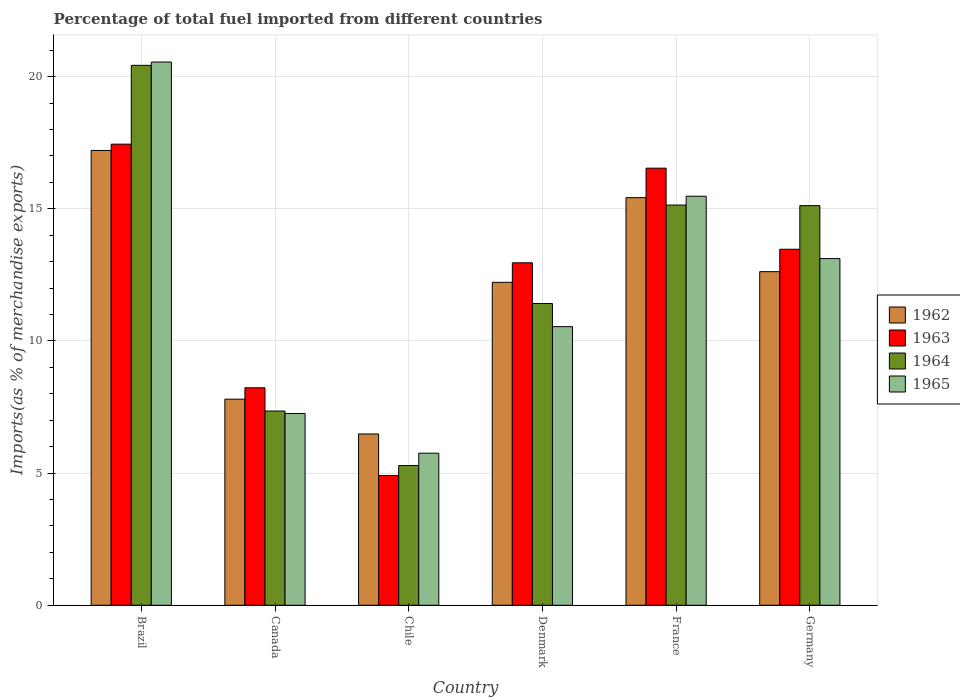How many different coloured bars are there?
Keep it short and to the point. 4. How many groups of bars are there?
Offer a very short reply. 6. Are the number of bars per tick equal to the number of legend labels?
Ensure brevity in your answer.  Yes. How many bars are there on the 2nd tick from the right?
Make the answer very short. 4. What is the label of the 1st group of bars from the left?
Your answer should be compact. Brazil. In how many cases, is the number of bars for a given country not equal to the number of legend labels?
Offer a terse response. 0. What is the percentage of imports to different countries in 1963 in Chile?
Ensure brevity in your answer.  4.91. Across all countries, what is the maximum percentage of imports to different countries in 1962?
Keep it short and to the point. 17.21. Across all countries, what is the minimum percentage of imports to different countries in 1962?
Provide a succinct answer. 6.48. What is the total percentage of imports to different countries in 1962 in the graph?
Give a very brief answer. 71.75. What is the difference between the percentage of imports to different countries in 1965 in Denmark and that in Germany?
Keep it short and to the point. -2.58. What is the difference between the percentage of imports to different countries in 1962 in Denmark and the percentage of imports to different countries in 1965 in Canada?
Provide a short and direct response. 4.96. What is the average percentage of imports to different countries in 1964 per country?
Give a very brief answer. 12.46. What is the difference between the percentage of imports to different countries of/in 1963 and percentage of imports to different countries of/in 1964 in Germany?
Your response must be concise. -1.65. In how many countries, is the percentage of imports to different countries in 1963 greater than 15 %?
Your answer should be very brief. 2. What is the ratio of the percentage of imports to different countries in 1964 in Chile to that in France?
Keep it short and to the point. 0.35. Is the difference between the percentage of imports to different countries in 1963 in Brazil and Chile greater than the difference between the percentage of imports to different countries in 1964 in Brazil and Chile?
Offer a very short reply. No. What is the difference between the highest and the second highest percentage of imports to different countries in 1965?
Offer a terse response. 7.44. What is the difference between the highest and the lowest percentage of imports to different countries in 1964?
Ensure brevity in your answer.  15.14. In how many countries, is the percentage of imports to different countries in 1965 greater than the average percentage of imports to different countries in 1965 taken over all countries?
Your answer should be very brief. 3. What does the 4th bar from the right in Canada represents?
Your answer should be very brief. 1962. Is it the case that in every country, the sum of the percentage of imports to different countries in 1963 and percentage of imports to different countries in 1962 is greater than the percentage of imports to different countries in 1964?
Offer a terse response. Yes. How many countries are there in the graph?
Your answer should be very brief. 6. What is the difference between two consecutive major ticks on the Y-axis?
Keep it short and to the point. 5. Are the values on the major ticks of Y-axis written in scientific E-notation?
Your response must be concise. No. Does the graph contain any zero values?
Give a very brief answer. No. Does the graph contain grids?
Make the answer very short. Yes. What is the title of the graph?
Provide a succinct answer. Percentage of total fuel imported from different countries. Does "2005" appear as one of the legend labels in the graph?
Your answer should be very brief. No. What is the label or title of the X-axis?
Your answer should be very brief. Country. What is the label or title of the Y-axis?
Keep it short and to the point. Imports(as % of merchandise exports). What is the Imports(as % of merchandise exports) of 1962 in Brazil?
Your answer should be compact. 17.21. What is the Imports(as % of merchandise exports) of 1963 in Brazil?
Provide a succinct answer. 17.45. What is the Imports(as % of merchandise exports) in 1964 in Brazil?
Keep it short and to the point. 20.43. What is the Imports(as % of merchandise exports) in 1965 in Brazil?
Your answer should be compact. 20.55. What is the Imports(as % of merchandise exports) of 1962 in Canada?
Give a very brief answer. 7.8. What is the Imports(as % of merchandise exports) of 1963 in Canada?
Offer a very short reply. 8.23. What is the Imports(as % of merchandise exports) in 1964 in Canada?
Provide a succinct answer. 7.35. What is the Imports(as % of merchandise exports) in 1965 in Canada?
Your response must be concise. 7.26. What is the Imports(as % of merchandise exports) of 1962 in Chile?
Offer a very short reply. 6.48. What is the Imports(as % of merchandise exports) in 1963 in Chile?
Ensure brevity in your answer.  4.91. What is the Imports(as % of merchandise exports) of 1964 in Chile?
Provide a succinct answer. 5.29. What is the Imports(as % of merchandise exports) in 1965 in Chile?
Provide a short and direct response. 5.75. What is the Imports(as % of merchandise exports) in 1962 in Denmark?
Offer a very short reply. 12.22. What is the Imports(as % of merchandise exports) of 1963 in Denmark?
Your response must be concise. 12.96. What is the Imports(as % of merchandise exports) of 1964 in Denmark?
Make the answer very short. 11.42. What is the Imports(as % of merchandise exports) in 1965 in Denmark?
Your response must be concise. 10.54. What is the Imports(as % of merchandise exports) of 1962 in France?
Make the answer very short. 15.42. What is the Imports(as % of merchandise exports) of 1963 in France?
Keep it short and to the point. 16.54. What is the Imports(as % of merchandise exports) of 1964 in France?
Offer a terse response. 15.14. What is the Imports(as % of merchandise exports) in 1965 in France?
Offer a very short reply. 15.48. What is the Imports(as % of merchandise exports) in 1962 in Germany?
Your answer should be very brief. 12.62. What is the Imports(as % of merchandise exports) in 1963 in Germany?
Keep it short and to the point. 13.47. What is the Imports(as % of merchandise exports) of 1964 in Germany?
Offer a terse response. 15.12. What is the Imports(as % of merchandise exports) in 1965 in Germany?
Provide a succinct answer. 13.12. Across all countries, what is the maximum Imports(as % of merchandise exports) of 1962?
Provide a short and direct response. 17.21. Across all countries, what is the maximum Imports(as % of merchandise exports) of 1963?
Provide a short and direct response. 17.45. Across all countries, what is the maximum Imports(as % of merchandise exports) in 1964?
Offer a terse response. 20.43. Across all countries, what is the maximum Imports(as % of merchandise exports) of 1965?
Give a very brief answer. 20.55. Across all countries, what is the minimum Imports(as % of merchandise exports) of 1962?
Your response must be concise. 6.48. Across all countries, what is the minimum Imports(as % of merchandise exports) in 1963?
Provide a succinct answer. 4.91. Across all countries, what is the minimum Imports(as % of merchandise exports) in 1964?
Offer a very short reply. 5.29. Across all countries, what is the minimum Imports(as % of merchandise exports) in 1965?
Provide a short and direct response. 5.75. What is the total Imports(as % of merchandise exports) in 1962 in the graph?
Provide a succinct answer. 71.75. What is the total Imports(as % of merchandise exports) of 1963 in the graph?
Your response must be concise. 73.55. What is the total Imports(as % of merchandise exports) of 1964 in the graph?
Offer a terse response. 74.75. What is the total Imports(as % of merchandise exports) of 1965 in the graph?
Keep it short and to the point. 72.7. What is the difference between the Imports(as % of merchandise exports) in 1962 in Brazil and that in Canada?
Your answer should be compact. 9.41. What is the difference between the Imports(as % of merchandise exports) of 1963 in Brazil and that in Canada?
Ensure brevity in your answer.  9.22. What is the difference between the Imports(as % of merchandise exports) of 1964 in Brazil and that in Canada?
Offer a very short reply. 13.08. What is the difference between the Imports(as % of merchandise exports) of 1965 in Brazil and that in Canada?
Your answer should be very brief. 13.3. What is the difference between the Imports(as % of merchandise exports) in 1962 in Brazil and that in Chile?
Ensure brevity in your answer.  10.73. What is the difference between the Imports(as % of merchandise exports) of 1963 in Brazil and that in Chile?
Provide a succinct answer. 12.54. What is the difference between the Imports(as % of merchandise exports) in 1964 in Brazil and that in Chile?
Keep it short and to the point. 15.14. What is the difference between the Imports(as % of merchandise exports) in 1965 in Brazil and that in Chile?
Make the answer very short. 14.8. What is the difference between the Imports(as % of merchandise exports) in 1962 in Brazil and that in Denmark?
Make the answer very short. 4.99. What is the difference between the Imports(as % of merchandise exports) in 1963 in Brazil and that in Denmark?
Your answer should be compact. 4.49. What is the difference between the Imports(as % of merchandise exports) in 1964 in Brazil and that in Denmark?
Your answer should be very brief. 9.01. What is the difference between the Imports(as % of merchandise exports) in 1965 in Brazil and that in Denmark?
Your response must be concise. 10.01. What is the difference between the Imports(as % of merchandise exports) in 1962 in Brazil and that in France?
Give a very brief answer. 1.79. What is the difference between the Imports(as % of merchandise exports) of 1963 in Brazil and that in France?
Keep it short and to the point. 0.91. What is the difference between the Imports(as % of merchandise exports) in 1964 in Brazil and that in France?
Provide a short and direct response. 5.29. What is the difference between the Imports(as % of merchandise exports) in 1965 in Brazil and that in France?
Offer a terse response. 5.08. What is the difference between the Imports(as % of merchandise exports) of 1962 in Brazil and that in Germany?
Give a very brief answer. 4.59. What is the difference between the Imports(as % of merchandise exports) of 1963 in Brazil and that in Germany?
Keep it short and to the point. 3.98. What is the difference between the Imports(as % of merchandise exports) of 1964 in Brazil and that in Germany?
Provide a short and direct response. 5.31. What is the difference between the Imports(as % of merchandise exports) in 1965 in Brazil and that in Germany?
Your answer should be compact. 7.44. What is the difference between the Imports(as % of merchandise exports) of 1962 in Canada and that in Chile?
Your answer should be compact. 1.32. What is the difference between the Imports(as % of merchandise exports) in 1963 in Canada and that in Chile?
Offer a terse response. 3.32. What is the difference between the Imports(as % of merchandise exports) of 1964 in Canada and that in Chile?
Your answer should be compact. 2.06. What is the difference between the Imports(as % of merchandise exports) of 1965 in Canada and that in Chile?
Keep it short and to the point. 1.5. What is the difference between the Imports(as % of merchandise exports) of 1962 in Canada and that in Denmark?
Your answer should be compact. -4.42. What is the difference between the Imports(as % of merchandise exports) of 1963 in Canada and that in Denmark?
Keep it short and to the point. -4.73. What is the difference between the Imports(as % of merchandise exports) in 1964 in Canada and that in Denmark?
Offer a terse response. -4.07. What is the difference between the Imports(as % of merchandise exports) of 1965 in Canada and that in Denmark?
Make the answer very short. -3.29. What is the difference between the Imports(as % of merchandise exports) of 1962 in Canada and that in France?
Your answer should be very brief. -7.62. What is the difference between the Imports(as % of merchandise exports) of 1963 in Canada and that in France?
Provide a short and direct response. -8.31. What is the difference between the Imports(as % of merchandise exports) in 1964 in Canada and that in France?
Provide a short and direct response. -7.79. What is the difference between the Imports(as % of merchandise exports) in 1965 in Canada and that in France?
Provide a short and direct response. -8.22. What is the difference between the Imports(as % of merchandise exports) in 1962 in Canada and that in Germany?
Your response must be concise. -4.82. What is the difference between the Imports(as % of merchandise exports) in 1963 in Canada and that in Germany?
Keep it short and to the point. -5.24. What is the difference between the Imports(as % of merchandise exports) of 1964 in Canada and that in Germany?
Make the answer very short. -7.77. What is the difference between the Imports(as % of merchandise exports) of 1965 in Canada and that in Germany?
Provide a short and direct response. -5.86. What is the difference between the Imports(as % of merchandise exports) of 1962 in Chile and that in Denmark?
Your response must be concise. -5.74. What is the difference between the Imports(as % of merchandise exports) in 1963 in Chile and that in Denmark?
Keep it short and to the point. -8.05. What is the difference between the Imports(as % of merchandise exports) in 1964 in Chile and that in Denmark?
Ensure brevity in your answer.  -6.13. What is the difference between the Imports(as % of merchandise exports) of 1965 in Chile and that in Denmark?
Offer a very short reply. -4.79. What is the difference between the Imports(as % of merchandise exports) in 1962 in Chile and that in France?
Offer a very short reply. -8.94. What is the difference between the Imports(as % of merchandise exports) in 1963 in Chile and that in France?
Your response must be concise. -11.63. What is the difference between the Imports(as % of merchandise exports) of 1964 in Chile and that in France?
Offer a terse response. -9.86. What is the difference between the Imports(as % of merchandise exports) of 1965 in Chile and that in France?
Provide a short and direct response. -9.72. What is the difference between the Imports(as % of merchandise exports) of 1962 in Chile and that in Germany?
Offer a very short reply. -6.14. What is the difference between the Imports(as % of merchandise exports) of 1963 in Chile and that in Germany?
Provide a succinct answer. -8.56. What is the difference between the Imports(as % of merchandise exports) in 1964 in Chile and that in Germany?
Offer a very short reply. -9.83. What is the difference between the Imports(as % of merchandise exports) in 1965 in Chile and that in Germany?
Provide a succinct answer. -7.36. What is the difference between the Imports(as % of merchandise exports) of 1962 in Denmark and that in France?
Provide a short and direct response. -3.2. What is the difference between the Imports(as % of merchandise exports) in 1963 in Denmark and that in France?
Make the answer very short. -3.58. What is the difference between the Imports(as % of merchandise exports) of 1964 in Denmark and that in France?
Give a very brief answer. -3.72. What is the difference between the Imports(as % of merchandise exports) of 1965 in Denmark and that in France?
Offer a terse response. -4.94. What is the difference between the Imports(as % of merchandise exports) of 1962 in Denmark and that in Germany?
Provide a short and direct response. -0.4. What is the difference between the Imports(as % of merchandise exports) of 1963 in Denmark and that in Germany?
Keep it short and to the point. -0.51. What is the difference between the Imports(as % of merchandise exports) of 1964 in Denmark and that in Germany?
Your answer should be compact. -3.7. What is the difference between the Imports(as % of merchandise exports) of 1965 in Denmark and that in Germany?
Offer a terse response. -2.58. What is the difference between the Imports(as % of merchandise exports) in 1962 in France and that in Germany?
Make the answer very short. 2.8. What is the difference between the Imports(as % of merchandise exports) in 1963 in France and that in Germany?
Keep it short and to the point. 3.07. What is the difference between the Imports(as % of merchandise exports) of 1964 in France and that in Germany?
Give a very brief answer. 0.02. What is the difference between the Imports(as % of merchandise exports) of 1965 in France and that in Germany?
Your response must be concise. 2.36. What is the difference between the Imports(as % of merchandise exports) in 1962 in Brazil and the Imports(as % of merchandise exports) in 1963 in Canada?
Provide a succinct answer. 8.98. What is the difference between the Imports(as % of merchandise exports) in 1962 in Brazil and the Imports(as % of merchandise exports) in 1964 in Canada?
Make the answer very short. 9.86. What is the difference between the Imports(as % of merchandise exports) in 1962 in Brazil and the Imports(as % of merchandise exports) in 1965 in Canada?
Ensure brevity in your answer.  9.95. What is the difference between the Imports(as % of merchandise exports) of 1963 in Brazil and the Imports(as % of merchandise exports) of 1964 in Canada?
Offer a terse response. 10.1. What is the difference between the Imports(as % of merchandise exports) in 1963 in Brazil and the Imports(as % of merchandise exports) in 1965 in Canada?
Give a very brief answer. 10.19. What is the difference between the Imports(as % of merchandise exports) of 1964 in Brazil and the Imports(as % of merchandise exports) of 1965 in Canada?
Make the answer very short. 13.17. What is the difference between the Imports(as % of merchandise exports) in 1962 in Brazil and the Imports(as % of merchandise exports) in 1963 in Chile?
Provide a short and direct response. 12.3. What is the difference between the Imports(as % of merchandise exports) of 1962 in Brazil and the Imports(as % of merchandise exports) of 1964 in Chile?
Provide a short and direct response. 11.92. What is the difference between the Imports(as % of merchandise exports) of 1962 in Brazil and the Imports(as % of merchandise exports) of 1965 in Chile?
Give a very brief answer. 11.46. What is the difference between the Imports(as % of merchandise exports) in 1963 in Brazil and the Imports(as % of merchandise exports) in 1964 in Chile?
Your response must be concise. 12.16. What is the difference between the Imports(as % of merchandise exports) of 1963 in Brazil and the Imports(as % of merchandise exports) of 1965 in Chile?
Make the answer very short. 11.69. What is the difference between the Imports(as % of merchandise exports) in 1964 in Brazil and the Imports(as % of merchandise exports) in 1965 in Chile?
Your answer should be compact. 14.68. What is the difference between the Imports(as % of merchandise exports) of 1962 in Brazil and the Imports(as % of merchandise exports) of 1963 in Denmark?
Your answer should be compact. 4.25. What is the difference between the Imports(as % of merchandise exports) of 1962 in Brazil and the Imports(as % of merchandise exports) of 1964 in Denmark?
Ensure brevity in your answer.  5.79. What is the difference between the Imports(as % of merchandise exports) of 1962 in Brazil and the Imports(as % of merchandise exports) of 1965 in Denmark?
Ensure brevity in your answer.  6.67. What is the difference between the Imports(as % of merchandise exports) of 1963 in Brazil and the Imports(as % of merchandise exports) of 1964 in Denmark?
Give a very brief answer. 6.03. What is the difference between the Imports(as % of merchandise exports) in 1963 in Brazil and the Imports(as % of merchandise exports) in 1965 in Denmark?
Give a very brief answer. 6.91. What is the difference between the Imports(as % of merchandise exports) of 1964 in Brazil and the Imports(as % of merchandise exports) of 1965 in Denmark?
Your response must be concise. 9.89. What is the difference between the Imports(as % of merchandise exports) in 1962 in Brazil and the Imports(as % of merchandise exports) in 1963 in France?
Offer a very short reply. 0.67. What is the difference between the Imports(as % of merchandise exports) in 1962 in Brazil and the Imports(as % of merchandise exports) in 1964 in France?
Provide a short and direct response. 2.07. What is the difference between the Imports(as % of merchandise exports) in 1962 in Brazil and the Imports(as % of merchandise exports) in 1965 in France?
Provide a short and direct response. 1.73. What is the difference between the Imports(as % of merchandise exports) of 1963 in Brazil and the Imports(as % of merchandise exports) of 1964 in France?
Offer a very short reply. 2.3. What is the difference between the Imports(as % of merchandise exports) of 1963 in Brazil and the Imports(as % of merchandise exports) of 1965 in France?
Your response must be concise. 1.97. What is the difference between the Imports(as % of merchandise exports) of 1964 in Brazil and the Imports(as % of merchandise exports) of 1965 in France?
Provide a short and direct response. 4.95. What is the difference between the Imports(as % of merchandise exports) in 1962 in Brazil and the Imports(as % of merchandise exports) in 1963 in Germany?
Your answer should be compact. 3.74. What is the difference between the Imports(as % of merchandise exports) of 1962 in Brazil and the Imports(as % of merchandise exports) of 1964 in Germany?
Your answer should be compact. 2.09. What is the difference between the Imports(as % of merchandise exports) of 1962 in Brazil and the Imports(as % of merchandise exports) of 1965 in Germany?
Offer a very short reply. 4.09. What is the difference between the Imports(as % of merchandise exports) of 1963 in Brazil and the Imports(as % of merchandise exports) of 1964 in Germany?
Your response must be concise. 2.33. What is the difference between the Imports(as % of merchandise exports) of 1963 in Brazil and the Imports(as % of merchandise exports) of 1965 in Germany?
Your answer should be very brief. 4.33. What is the difference between the Imports(as % of merchandise exports) in 1964 in Brazil and the Imports(as % of merchandise exports) in 1965 in Germany?
Offer a terse response. 7.31. What is the difference between the Imports(as % of merchandise exports) of 1962 in Canada and the Imports(as % of merchandise exports) of 1963 in Chile?
Provide a short and direct response. 2.89. What is the difference between the Imports(as % of merchandise exports) in 1962 in Canada and the Imports(as % of merchandise exports) in 1964 in Chile?
Your answer should be very brief. 2.51. What is the difference between the Imports(as % of merchandise exports) of 1962 in Canada and the Imports(as % of merchandise exports) of 1965 in Chile?
Provide a short and direct response. 2.04. What is the difference between the Imports(as % of merchandise exports) in 1963 in Canada and the Imports(as % of merchandise exports) in 1964 in Chile?
Give a very brief answer. 2.94. What is the difference between the Imports(as % of merchandise exports) in 1963 in Canada and the Imports(as % of merchandise exports) in 1965 in Chile?
Your answer should be very brief. 2.48. What is the difference between the Imports(as % of merchandise exports) of 1964 in Canada and the Imports(as % of merchandise exports) of 1965 in Chile?
Offer a terse response. 1.6. What is the difference between the Imports(as % of merchandise exports) of 1962 in Canada and the Imports(as % of merchandise exports) of 1963 in Denmark?
Keep it short and to the point. -5.16. What is the difference between the Imports(as % of merchandise exports) in 1962 in Canada and the Imports(as % of merchandise exports) in 1964 in Denmark?
Give a very brief answer. -3.62. What is the difference between the Imports(as % of merchandise exports) of 1962 in Canada and the Imports(as % of merchandise exports) of 1965 in Denmark?
Give a very brief answer. -2.74. What is the difference between the Imports(as % of merchandise exports) in 1963 in Canada and the Imports(as % of merchandise exports) in 1964 in Denmark?
Your answer should be very brief. -3.19. What is the difference between the Imports(as % of merchandise exports) in 1963 in Canada and the Imports(as % of merchandise exports) in 1965 in Denmark?
Give a very brief answer. -2.31. What is the difference between the Imports(as % of merchandise exports) of 1964 in Canada and the Imports(as % of merchandise exports) of 1965 in Denmark?
Your response must be concise. -3.19. What is the difference between the Imports(as % of merchandise exports) in 1962 in Canada and the Imports(as % of merchandise exports) in 1963 in France?
Offer a very short reply. -8.74. What is the difference between the Imports(as % of merchandise exports) of 1962 in Canada and the Imports(as % of merchandise exports) of 1964 in France?
Your answer should be very brief. -7.35. What is the difference between the Imports(as % of merchandise exports) of 1962 in Canada and the Imports(as % of merchandise exports) of 1965 in France?
Offer a terse response. -7.68. What is the difference between the Imports(as % of merchandise exports) in 1963 in Canada and the Imports(as % of merchandise exports) in 1964 in France?
Keep it short and to the point. -6.91. What is the difference between the Imports(as % of merchandise exports) of 1963 in Canada and the Imports(as % of merchandise exports) of 1965 in France?
Offer a very short reply. -7.25. What is the difference between the Imports(as % of merchandise exports) of 1964 in Canada and the Imports(as % of merchandise exports) of 1965 in France?
Give a very brief answer. -8.13. What is the difference between the Imports(as % of merchandise exports) in 1962 in Canada and the Imports(as % of merchandise exports) in 1963 in Germany?
Give a very brief answer. -5.67. What is the difference between the Imports(as % of merchandise exports) in 1962 in Canada and the Imports(as % of merchandise exports) in 1964 in Germany?
Your answer should be compact. -7.32. What is the difference between the Imports(as % of merchandise exports) of 1962 in Canada and the Imports(as % of merchandise exports) of 1965 in Germany?
Provide a short and direct response. -5.32. What is the difference between the Imports(as % of merchandise exports) in 1963 in Canada and the Imports(as % of merchandise exports) in 1964 in Germany?
Provide a short and direct response. -6.89. What is the difference between the Imports(as % of merchandise exports) of 1963 in Canada and the Imports(as % of merchandise exports) of 1965 in Germany?
Make the answer very short. -4.89. What is the difference between the Imports(as % of merchandise exports) in 1964 in Canada and the Imports(as % of merchandise exports) in 1965 in Germany?
Offer a very short reply. -5.77. What is the difference between the Imports(as % of merchandise exports) in 1962 in Chile and the Imports(as % of merchandise exports) in 1963 in Denmark?
Offer a very short reply. -6.48. What is the difference between the Imports(as % of merchandise exports) of 1962 in Chile and the Imports(as % of merchandise exports) of 1964 in Denmark?
Keep it short and to the point. -4.94. What is the difference between the Imports(as % of merchandise exports) of 1962 in Chile and the Imports(as % of merchandise exports) of 1965 in Denmark?
Provide a short and direct response. -4.06. What is the difference between the Imports(as % of merchandise exports) in 1963 in Chile and the Imports(as % of merchandise exports) in 1964 in Denmark?
Provide a short and direct response. -6.51. What is the difference between the Imports(as % of merchandise exports) in 1963 in Chile and the Imports(as % of merchandise exports) in 1965 in Denmark?
Provide a succinct answer. -5.63. What is the difference between the Imports(as % of merchandise exports) of 1964 in Chile and the Imports(as % of merchandise exports) of 1965 in Denmark?
Your answer should be compact. -5.25. What is the difference between the Imports(as % of merchandise exports) in 1962 in Chile and the Imports(as % of merchandise exports) in 1963 in France?
Your response must be concise. -10.06. What is the difference between the Imports(as % of merchandise exports) of 1962 in Chile and the Imports(as % of merchandise exports) of 1964 in France?
Offer a terse response. -8.66. What is the difference between the Imports(as % of merchandise exports) of 1962 in Chile and the Imports(as % of merchandise exports) of 1965 in France?
Your response must be concise. -9. What is the difference between the Imports(as % of merchandise exports) of 1963 in Chile and the Imports(as % of merchandise exports) of 1964 in France?
Give a very brief answer. -10.23. What is the difference between the Imports(as % of merchandise exports) of 1963 in Chile and the Imports(as % of merchandise exports) of 1965 in France?
Provide a succinct answer. -10.57. What is the difference between the Imports(as % of merchandise exports) in 1964 in Chile and the Imports(as % of merchandise exports) in 1965 in France?
Make the answer very short. -10.19. What is the difference between the Imports(as % of merchandise exports) of 1962 in Chile and the Imports(as % of merchandise exports) of 1963 in Germany?
Ensure brevity in your answer.  -6.99. What is the difference between the Imports(as % of merchandise exports) of 1962 in Chile and the Imports(as % of merchandise exports) of 1964 in Germany?
Your answer should be very brief. -8.64. What is the difference between the Imports(as % of merchandise exports) of 1962 in Chile and the Imports(as % of merchandise exports) of 1965 in Germany?
Your answer should be very brief. -6.64. What is the difference between the Imports(as % of merchandise exports) in 1963 in Chile and the Imports(as % of merchandise exports) in 1964 in Germany?
Keep it short and to the point. -10.21. What is the difference between the Imports(as % of merchandise exports) in 1963 in Chile and the Imports(as % of merchandise exports) in 1965 in Germany?
Your answer should be compact. -8.21. What is the difference between the Imports(as % of merchandise exports) of 1964 in Chile and the Imports(as % of merchandise exports) of 1965 in Germany?
Your answer should be compact. -7.83. What is the difference between the Imports(as % of merchandise exports) in 1962 in Denmark and the Imports(as % of merchandise exports) in 1963 in France?
Provide a short and direct response. -4.32. What is the difference between the Imports(as % of merchandise exports) of 1962 in Denmark and the Imports(as % of merchandise exports) of 1964 in France?
Provide a short and direct response. -2.92. What is the difference between the Imports(as % of merchandise exports) in 1962 in Denmark and the Imports(as % of merchandise exports) in 1965 in France?
Offer a very short reply. -3.26. What is the difference between the Imports(as % of merchandise exports) in 1963 in Denmark and the Imports(as % of merchandise exports) in 1964 in France?
Provide a short and direct response. -2.19. What is the difference between the Imports(as % of merchandise exports) of 1963 in Denmark and the Imports(as % of merchandise exports) of 1965 in France?
Keep it short and to the point. -2.52. What is the difference between the Imports(as % of merchandise exports) in 1964 in Denmark and the Imports(as % of merchandise exports) in 1965 in France?
Provide a short and direct response. -4.06. What is the difference between the Imports(as % of merchandise exports) in 1962 in Denmark and the Imports(as % of merchandise exports) in 1963 in Germany?
Offer a terse response. -1.25. What is the difference between the Imports(as % of merchandise exports) of 1962 in Denmark and the Imports(as % of merchandise exports) of 1964 in Germany?
Provide a short and direct response. -2.9. What is the difference between the Imports(as % of merchandise exports) of 1962 in Denmark and the Imports(as % of merchandise exports) of 1965 in Germany?
Offer a terse response. -0.9. What is the difference between the Imports(as % of merchandise exports) in 1963 in Denmark and the Imports(as % of merchandise exports) in 1964 in Germany?
Ensure brevity in your answer.  -2.16. What is the difference between the Imports(as % of merchandise exports) of 1963 in Denmark and the Imports(as % of merchandise exports) of 1965 in Germany?
Provide a succinct answer. -0.16. What is the difference between the Imports(as % of merchandise exports) in 1964 in Denmark and the Imports(as % of merchandise exports) in 1965 in Germany?
Offer a terse response. -1.7. What is the difference between the Imports(as % of merchandise exports) of 1962 in France and the Imports(as % of merchandise exports) of 1963 in Germany?
Give a very brief answer. 1.95. What is the difference between the Imports(as % of merchandise exports) in 1962 in France and the Imports(as % of merchandise exports) in 1964 in Germany?
Offer a very short reply. 0.3. What is the difference between the Imports(as % of merchandise exports) of 1962 in France and the Imports(as % of merchandise exports) of 1965 in Germany?
Offer a terse response. 2.31. What is the difference between the Imports(as % of merchandise exports) of 1963 in France and the Imports(as % of merchandise exports) of 1964 in Germany?
Provide a succinct answer. 1.42. What is the difference between the Imports(as % of merchandise exports) in 1963 in France and the Imports(as % of merchandise exports) in 1965 in Germany?
Offer a terse response. 3.42. What is the difference between the Imports(as % of merchandise exports) of 1964 in France and the Imports(as % of merchandise exports) of 1965 in Germany?
Provide a succinct answer. 2.03. What is the average Imports(as % of merchandise exports) in 1962 per country?
Make the answer very short. 11.96. What is the average Imports(as % of merchandise exports) in 1963 per country?
Your answer should be very brief. 12.26. What is the average Imports(as % of merchandise exports) of 1964 per country?
Your answer should be very brief. 12.46. What is the average Imports(as % of merchandise exports) of 1965 per country?
Offer a very short reply. 12.12. What is the difference between the Imports(as % of merchandise exports) in 1962 and Imports(as % of merchandise exports) in 1963 in Brazil?
Provide a short and direct response. -0.24. What is the difference between the Imports(as % of merchandise exports) in 1962 and Imports(as % of merchandise exports) in 1964 in Brazil?
Provide a short and direct response. -3.22. What is the difference between the Imports(as % of merchandise exports) in 1962 and Imports(as % of merchandise exports) in 1965 in Brazil?
Make the answer very short. -3.35. What is the difference between the Imports(as % of merchandise exports) of 1963 and Imports(as % of merchandise exports) of 1964 in Brazil?
Give a very brief answer. -2.98. What is the difference between the Imports(as % of merchandise exports) of 1963 and Imports(as % of merchandise exports) of 1965 in Brazil?
Offer a very short reply. -3.11. What is the difference between the Imports(as % of merchandise exports) in 1964 and Imports(as % of merchandise exports) in 1965 in Brazil?
Give a very brief answer. -0.12. What is the difference between the Imports(as % of merchandise exports) in 1962 and Imports(as % of merchandise exports) in 1963 in Canada?
Provide a short and direct response. -0.43. What is the difference between the Imports(as % of merchandise exports) in 1962 and Imports(as % of merchandise exports) in 1964 in Canada?
Keep it short and to the point. 0.45. What is the difference between the Imports(as % of merchandise exports) of 1962 and Imports(as % of merchandise exports) of 1965 in Canada?
Your response must be concise. 0.54. What is the difference between the Imports(as % of merchandise exports) of 1963 and Imports(as % of merchandise exports) of 1964 in Canada?
Keep it short and to the point. 0.88. What is the difference between the Imports(as % of merchandise exports) of 1963 and Imports(as % of merchandise exports) of 1965 in Canada?
Give a very brief answer. 0.97. What is the difference between the Imports(as % of merchandise exports) in 1964 and Imports(as % of merchandise exports) in 1965 in Canada?
Your response must be concise. 0.09. What is the difference between the Imports(as % of merchandise exports) of 1962 and Imports(as % of merchandise exports) of 1963 in Chile?
Offer a terse response. 1.57. What is the difference between the Imports(as % of merchandise exports) in 1962 and Imports(as % of merchandise exports) in 1964 in Chile?
Offer a very short reply. 1.19. What is the difference between the Imports(as % of merchandise exports) in 1962 and Imports(as % of merchandise exports) in 1965 in Chile?
Ensure brevity in your answer.  0.73. What is the difference between the Imports(as % of merchandise exports) of 1963 and Imports(as % of merchandise exports) of 1964 in Chile?
Make the answer very short. -0.38. What is the difference between the Imports(as % of merchandise exports) of 1963 and Imports(as % of merchandise exports) of 1965 in Chile?
Your answer should be compact. -0.84. What is the difference between the Imports(as % of merchandise exports) in 1964 and Imports(as % of merchandise exports) in 1965 in Chile?
Your answer should be compact. -0.47. What is the difference between the Imports(as % of merchandise exports) in 1962 and Imports(as % of merchandise exports) in 1963 in Denmark?
Provide a succinct answer. -0.74. What is the difference between the Imports(as % of merchandise exports) in 1962 and Imports(as % of merchandise exports) in 1964 in Denmark?
Your answer should be very brief. 0.8. What is the difference between the Imports(as % of merchandise exports) of 1962 and Imports(as % of merchandise exports) of 1965 in Denmark?
Your response must be concise. 1.68. What is the difference between the Imports(as % of merchandise exports) of 1963 and Imports(as % of merchandise exports) of 1964 in Denmark?
Keep it short and to the point. 1.54. What is the difference between the Imports(as % of merchandise exports) of 1963 and Imports(as % of merchandise exports) of 1965 in Denmark?
Your response must be concise. 2.42. What is the difference between the Imports(as % of merchandise exports) of 1964 and Imports(as % of merchandise exports) of 1965 in Denmark?
Your answer should be compact. 0.88. What is the difference between the Imports(as % of merchandise exports) of 1962 and Imports(as % of merchandise exports) of 1963 in France?
Make the answer very short. -1.12. What is the difference between the Imports(as % of merchandise exports) of 1962 and Imports(as % of merchandise exports) of 1964 in France?
Offer a very short reply. 0.28. What is the difference between the Imports(as % of merchandise exports) in 1962 and Imports(as % of merchandise exports) in 1965 in France?
Provide a short and direct response. -0.05. What is the difference between the Imports(as % of merchandise exports) of 1963 and Imports(as % of merchandise exports) of 1964 in France?
Give a very brief answer. 1.39. What is the difference between the Imports(as % of merchandise exports) of 1963 and Imports(as % of merchandise exports) of 1965 in France?
Make the answer very short. 1.06. What is the difference between the Imports(as % of merchandise exports) in 1964 and Imports(as % of merchandise exports) in 1965 in France?
Ensure brevity in your answer.  -0.33. What is the difference between the Imports(as % of merchandise exports) of 1962 and Imports(as % of merchandise exports) of 1963 in Germany?
Your answer should be very brief. -0.85. What is the difference between the Imports(as % of merchandise exports) of 1962 and Imports(as % of merchandise exports) of 1964 in Germany?
Keep it short and to the point. -2.5. What is the difference between the Imports(as % of merchandise exports) in 1962 and Imports(as % of merchandise exports) in 1965 in Germany?
Your answer should be compact. -0.49. What is the difference between the Imports(as % of merchandise exports) of 1963 and Imports(as % of merchandise exports) of 1964 in Germany?
Keep it short and to the point. -1.65. What is the difference between the Imports(as % of merchandise exports) in 1963 and Imports(as % of merchandise exports) in 1965 in Germany?
Keep it short and to the point. 0.35. What is the difference between the Imports(as % of merchandise exports) of 1964 and Imports(as % of merchandise exports) of 1965 in Germany?
Keep it short and to the point. 2. What is the ratio of the Imports(as % of merchandise exports) in 1962 in Brazil to that in Canada?
Make the answer very short. 2.21. What is the ratio of the Imports(as % of merchandise exports) of 1963 in Brazil to that in Canada?
Ensure brevity in your answer.  2.12. What is the ratio of the Imports(as % of merchandise exports) in 1964 in Brazil to that in Canada?
Provide a succinct answer. 2.78. What is the ratio of the Imports(as % of merchandise exports) in 1965 in Brazil to that in Canada?
Your answer should be compact. 2.83. What is the ratio of the Imports(as % of merchandise exports) in 1962 in Brazil to that in Chile?
Provide a short and direct response. 2.65. What is the ratio of the Imports(as % of merchandise exports) in 1963 in Brazil to that in Chile?
Give a very brief answer. 3.55. What is the ratio of the Imports(as % of merchandise exports) in 1964 in Brazil to that in Chile?
Your answer should be compact. 3.86. What is the ratio of the Imports(as % of merchandise exports) of 1965 in Brazil to that in Chile?
Keep it short and to the point. 3.57. What is the ratio of the Imports(as % of merchandise exports) of 1962 in Brazil to that in Denmark?
Provide a succinct answer. 1.41. What is the ratio of the Imports(as % of merchandise exports) in 1963 in Brazil to that in Denmark?
Make the answer very short. 1.35. What is the ratio of the Imports(as % of merchandise exports) of 1964 in Brazil to that in Denmark?
Offer a very short reply. 1.79. What is the ratio of the Imports(as % of merchandise exports) in 1965 in Brazil to that in Denmark?
Offer a terse response. 1.95. What is the ratio of the Imports(as % of merchandise exports) in 1962 in Brazil to that in France?
Offer a very short reply. 1.12. What is the ratio of the Imports(as % of merchandise exports) of 1963 in Brazil to that in France?
Provide a short and direct response. 1.05. What is the ratio of the Imports(as % of merchandise exports) in 1964 in Brazil to that in France?
Make the answer very short. 1.35. What is the ratio of the Imports(as % of merchandise exports) of 1965 in Brazil to that in France?
Offer a terse response. 1.33. What is the ratio of the Imports(as % of merchandise exports) in 1962 in Brazil to that in Germany?
Provide a short and direct response. 1.36. What is the ratio of the Imports(as % of merchandise exports) of 1963 in Brazil to that in Germany?
Give a very brief answer. 1.3. What is the ratio of the Imports(as % of merchandise exports) in 1964 in Brazil to that in Germany?
Provide a short and direct response. 1.35. What is the ratio of the Imports(as % of merchandise exports) of 1965 in Brazil to that in Germany?
Make the answer very short. 1.57. What is the ratio of the Imports(as % of merchandise exports) in 1962 in Canada to that in Chile?
Provide a short and direct response. 1.2. What is the ratio of the Imports(as % of merchandise exports) in 1963 in Canada to that in Chile?
Offer a very short reply. 1.68. What is the ratio of the Imports(as % of merchandise exports) of 1964 in Canada to that in Chile?
Give a very brief answer. 1.39. What is the ratio of the Imports(as % of merchandise exports) in 1965 in Canada to that in Chile?
Offer a terse response. 1.26. What is the ratio of the Imports(as % of merchandise exports) in 1962 in Canada to that in Denmark?
Provide a succinct answer. 0.64. What is the ratio of the Imports(as % of merchandise exports) in 1963 in Canada to that in Denmark?
Provide a short and direct response. 0.64. What is the ratio of the Imports(as % of merchandise exports) of 1964 in Canada to that in Denmark?
Keep it short and to the point. 0.64. What is the ratio of the Imports(as % of merchandise exports) of 1965 in Canada to that in Denmark?
Keep it short and to the point. 0.69. What is the ratio of the Imports(as % of merchandise exports) of 1962 in Canada to that in France?
Keep it short and to the point. 0.51. What is the ratio of the Imports(as % of merchandise exports) of 1963 in Canada to that in France?
Keep it short and to the point. 0.5. What is the ratio of the Imports(as % of merchandise exports) in 1964 in Canada to that in France?
Give a very brief answer. 0.49. What is the ratio of the Imports(as % of merchandise exports) of 1965 in Canada to that in France?
Your answer should be compact. 0.47. What is the ratio of the Imports(as % of merchandise exports) of 1962 in Canada to that in Germany?
Offer a very short reply. 0.62. What is the ratio of the Imports(as % of merchandise exports) in 1963 in Canada to that in Germany?
Your answer should be very brief. 0.61. What is the ratio of the Imports(as % of merchandise exports) of 1964 in Canada to that in Germany?
Give a very brief answer. 0.49. What is the ratio of the Imports(as % of merchandise exports) in 1965 in Canada to that in Germany?
Your answer should be very brief. 0.55. What is the ratio of the Imports(as % of merchandise exports) of 1962 in Chile to that in Denmark?
Offer a terse response. 0.53. What is the ratio of the Imports(as % of merchandise exports) of 1963 in Chile to that in Denmark?
Give a very brief answer. 0.38. What is the ratio of the Imports(as % of merchandise exports) in 1964 in Chile to that in Denmark?
Offer a terse response. 0.46. What is the ratio of the Imports(as % of merchandise exports) of 1965 in Chile to that in Denmark?
Offer a very short reply. 0.55. What is the ratio of the Imports(as % of merchandise exports) in 1962 in Chile to that in France?
Provide a short and direct response. 0.42. What is the ratio of the Imports(as % of merchandise exports) in 1963 in Chile to that in France?
Offer a very short reply. 0.3. What is the ratio of the Imports(as % of merchandise exports) in 1964 in Chile to that in France?
Provide a succinct answer. 0.35. What is the ratio of the Imports(as % of merchandise exports) of 1965 in Chile to that in France?
Make the answer very short. 0.37. What is the ratio of the Imports(as % of merchandise exports) in 1962 in Chile to that in Germany?
Your response must be concise. 0.51. What is the ratio of the Imports(as % of merchandise exports) of 1963 in Chile to that in Germany?
Make the answer very short. 0.36. What is the ratio of the Imports(as % of merchandise exports) of 1964 in Chile to that in Germany?
Your answer should be very brief. 0.35. What is the ratio of the Imports(as % of merchandise exports) of 1965 in Chile to that in Germany?
Your answer should be compact. 0.44. What is the ratio of the Imports(as % of merchandise exports) of 1962 in Denmark to that in France?
Provide a short and direct response. 0.79. What is the ratio of the Imports(as % of merchandise exports) of 1963 in Denmark to that in France?
Provide a short and direct response. 0.78. What is the ratio of the Imports(as % of merchandise exports) of 1964 in Denmark to that in France?
Make the answer very short. 0.75. What is the ratio of the Imports(as % of merchandise exports) of 1965 in Denmark to that in France?
Your answer should be very brief. 0.68. What is the ratio of the Imports(as % of merchandise exports) of 1963 in Denmark to that in Germany?
Offer a terse response. 0.96. What is the ratio of the Imports(as % of merchandise exports) in 1964 in Denmark to that in Germany?
Make the answer very short. 0.76. What is the ratio of the Imports(as % of merchandise exports) in 1965 in Denmark to that in Germany?
Provide a succinct answer. 0.8. What is the ratio of the Imports(as % of merchandise exports) of 1962 in France to that in Germany?
Give a very brief answer. 1.22. What is the ratio of the Imports(as % of merchandise exports) of 1963 in France to that in Germany?
Ensure brevity in your answer.  1.23. What is the ratio of the Imports(as % of merchandise exports) in 1964 in France to that in Germany?
Provide a short and direct response. 1. What is the ratio of the Imports(as % of merchandise exports) of 1965 in France to that in Germany?
Offer a very short reply. 1.18. What is the difference between the highest and the second highest Imports(as % of merchandise exports) in 1962?
Make the answer very short. 1.79. What is the difference between the highest and the second highest Imports(as % of merchandise exports) in 1963?
Your response must be concise. 0.91. What is the difference between the highest and the second highest Imports(as % of merchandise exports) in 1964?
Your answer should be very brief. 5.29. What is the difference between the highest and the second highest Imports(as % of merchandise exports) in 1965?
Keep it short and to the point. 5.08. What is the difference between the highest and the lowest Imports(as % of merchandise exports) in 1962?
Keep it short and to the point. 10.73. What is the difference between the highest and the lowest Imports(as % of merchandise exports) in 1963?
Give a very brief answer. 12.54. What is the difference between the highest and the lowest Imports(as % of merchandise exports) of 1964?
Offer a terse response. 15.14. What is the difference between the highest and the lowest Imports(as % of merchandise exports) in 1965?
Your answer should be very brief. 14.8. 